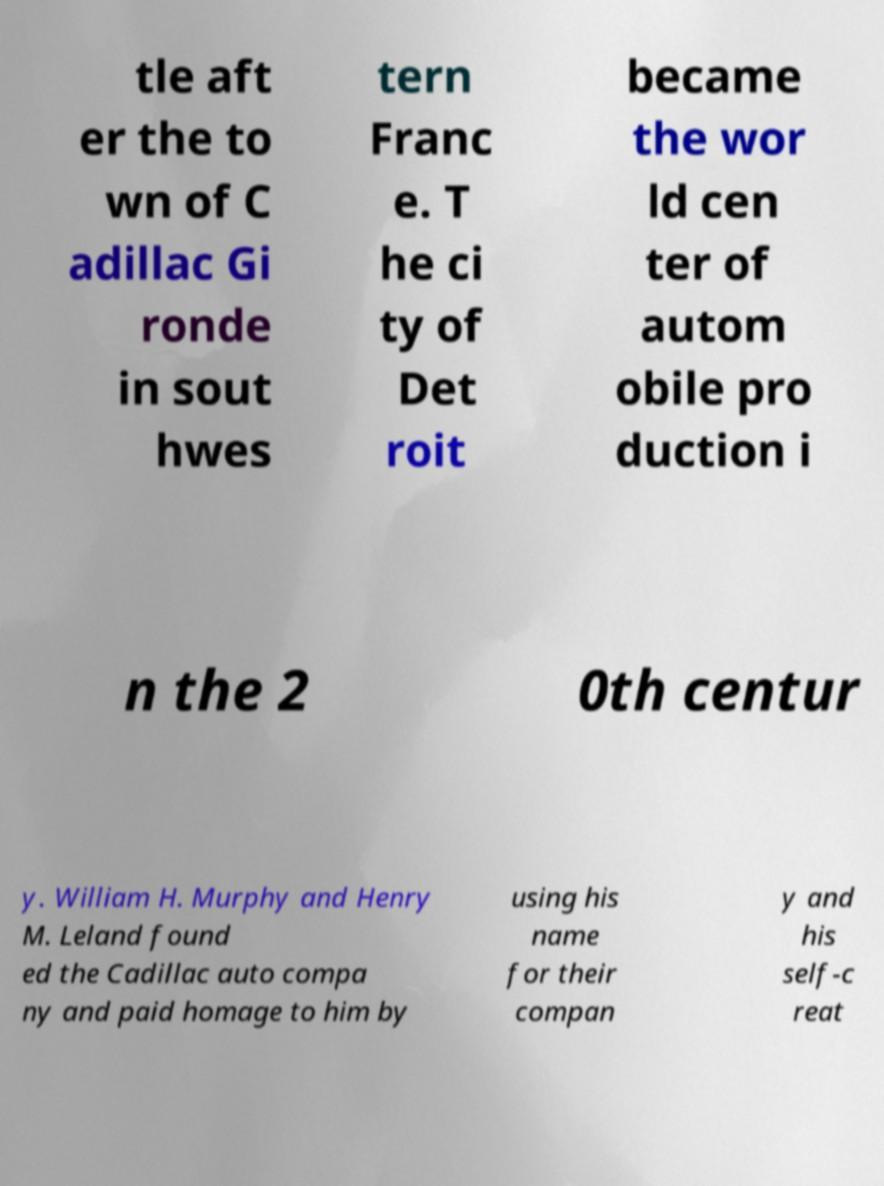Can you read and provide the text displayed in the image?This photo seems to have some interesting text. Can you extract and type it out for me? tle aft er the to wn of C adillac Gi ronde in sout hwes tern Franc e. T he ci ty of Det roit became the wor ld cen ter of autom obile pro duction i n the 2 0th centur y. William H. Murphy and Henry M. Leland found ed the Cadillac auto compa ny and paid homage to him by using his name for their compan y and his self-c reat 